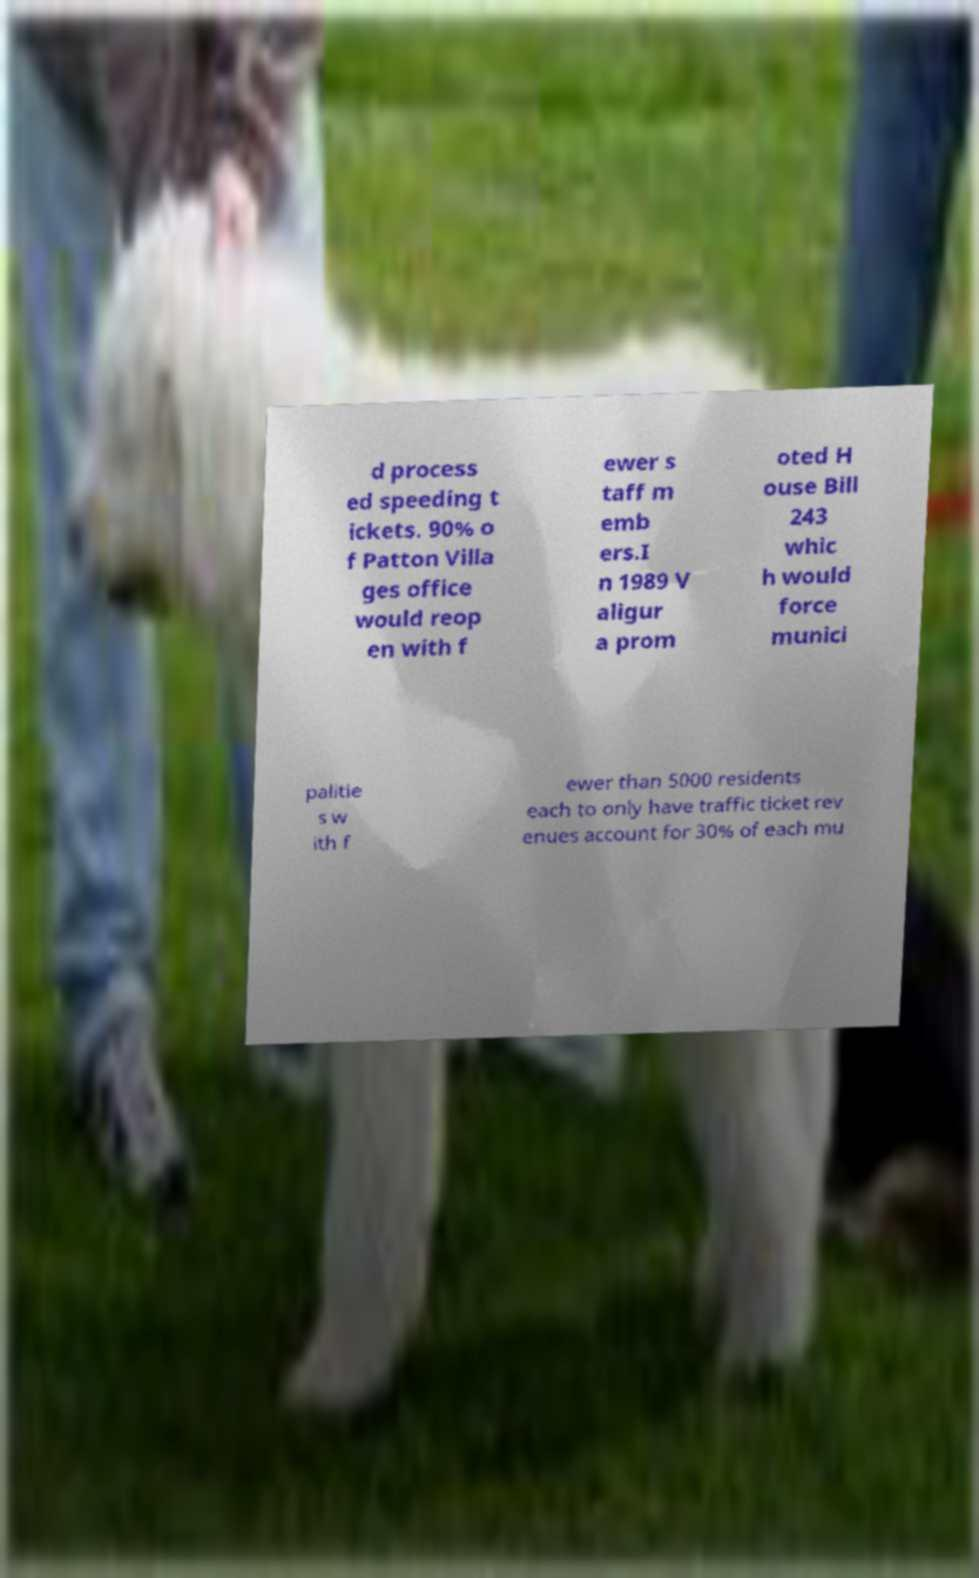Could you extract and type out the text from this image? d process ed speeding t ickets. 90% o f Patton Villa ges office would reop en with f ewer s taff m emb ers.I n 1989 V aligur a prom oted H ouse Bill 243 whic h would force munici palitie s w ith f ewer than 5000 residents each to only have traffic ticket rev enues account for 30% of each mu 